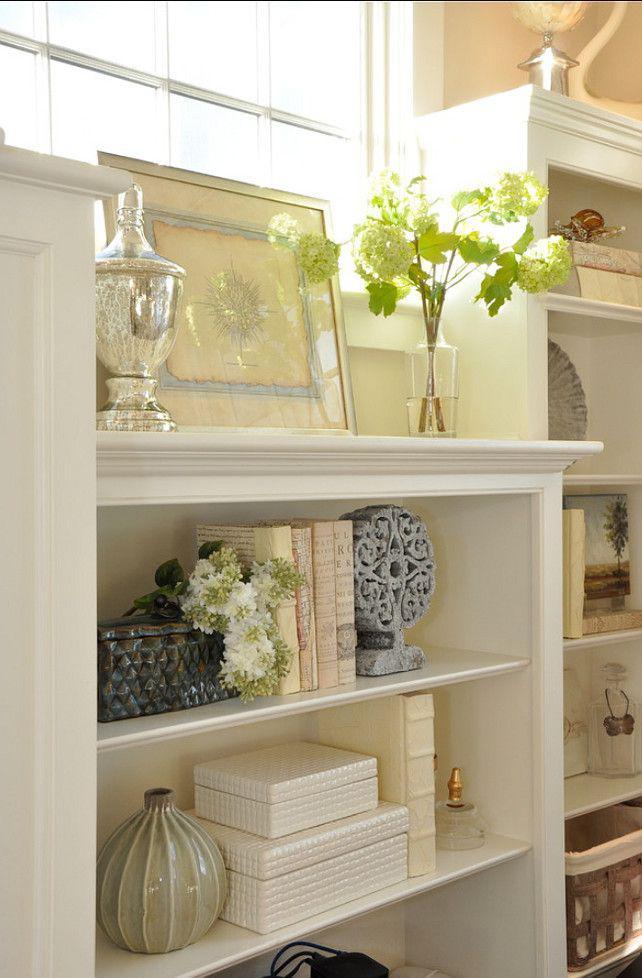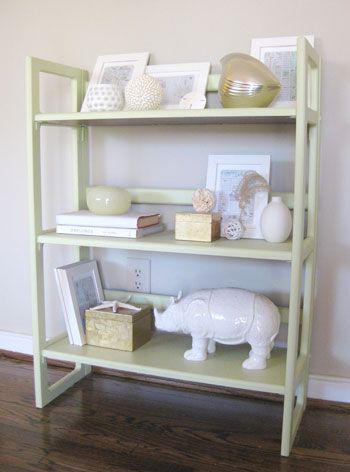The first image is the image on the left, the second image is the image on the right. Evaluate the accuracy of this statement regarding the images: "there is a chair in the image on the left". Is it true? Answer yes or no. No. The first image is the image on the left, the second image is the image on the right. Given the left and right images, does the statement "In at least one image, a shelving unit is used as a room divider." hold true? Answer yes or no. No. 